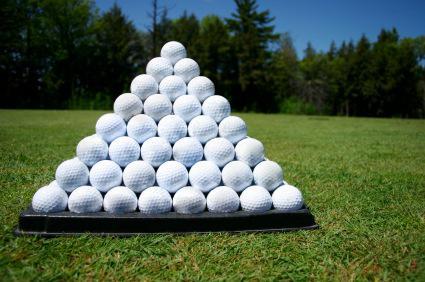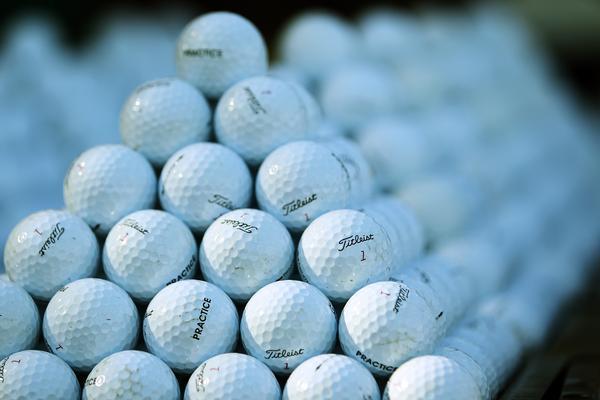The first image is the image on the left, the second image is the image on the right. Assess this claim about the two images: "At least one pink golf ball can be seen in a large pile of mostly white golf balls in one image.". Correct or not? Answer yes or no. No. The first image is the image on the left, the second image is the image on the right. Analyze the images presented: Is the assertion "At least one image shows white golf balls in a mesh-type green basket." valid? Answer yes or no. No. 